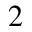Convert formula to latex. <formula><loc_0><loc_0><loc_500><loc_500>_ { 2 }</formula> 